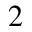Convert formula to latex. <formula><loc_0><loc_0><loc_500><loc_500>_ { 2 }</formula> 